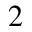Convert formula to latex. <formula><loc_0><loc_0><loc_500><loc_500>_ { 2 }</formula> 